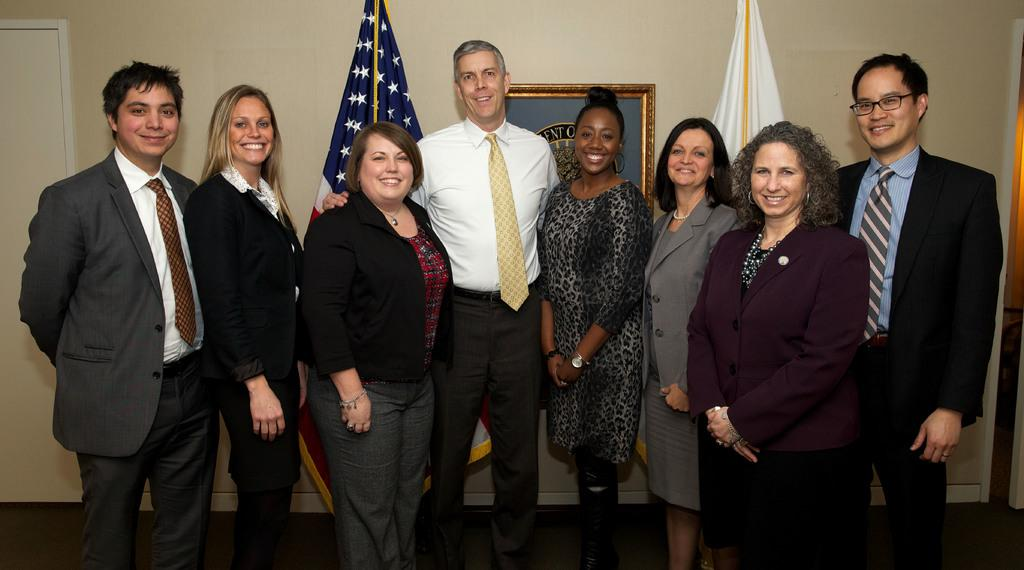How many people are in the image? There is a group of people in the image. What are the people doing in the image? The people are standing and smiling. What can be seen in the background of the image? There are flags and a frame on the wall visible in the background of the image. How many spiders are crawling on the people in the image? There are no spiders visible in the image; the people are standing and smiling. What type of street is shown in the image? The image does not show a street; it is focused on the group of people and the background elements. 